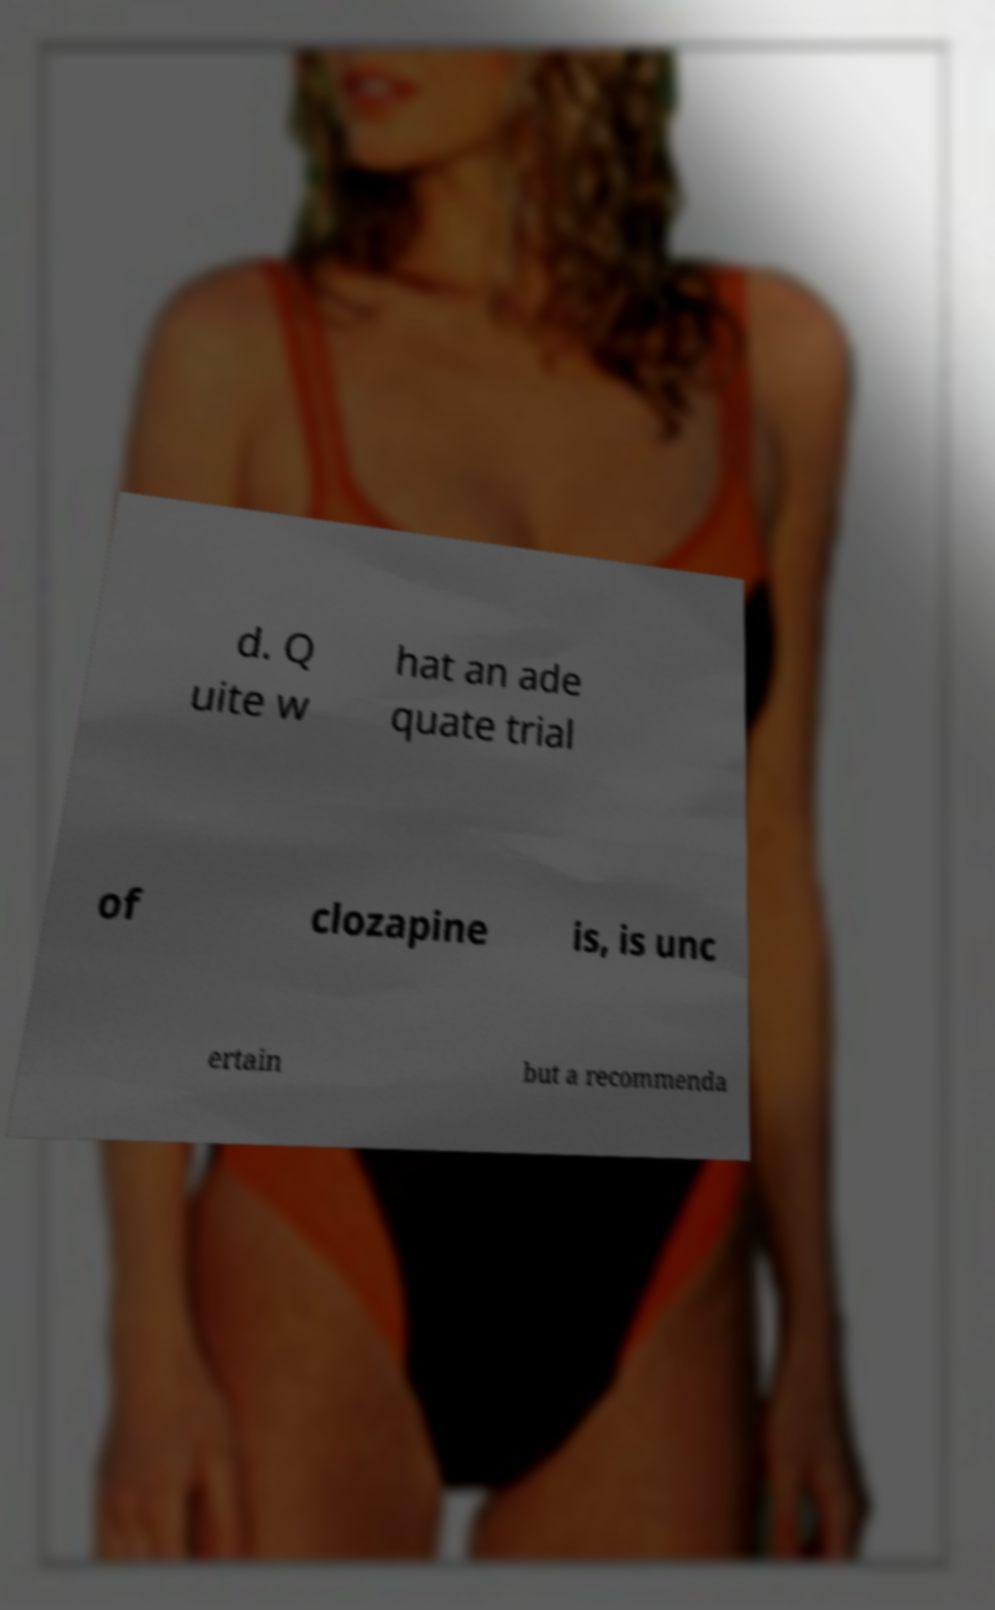Could you extract and type out the text from this image? d. Q uite w hat an ade quate trial of clozapine is, is unc ertain but a recommenda 